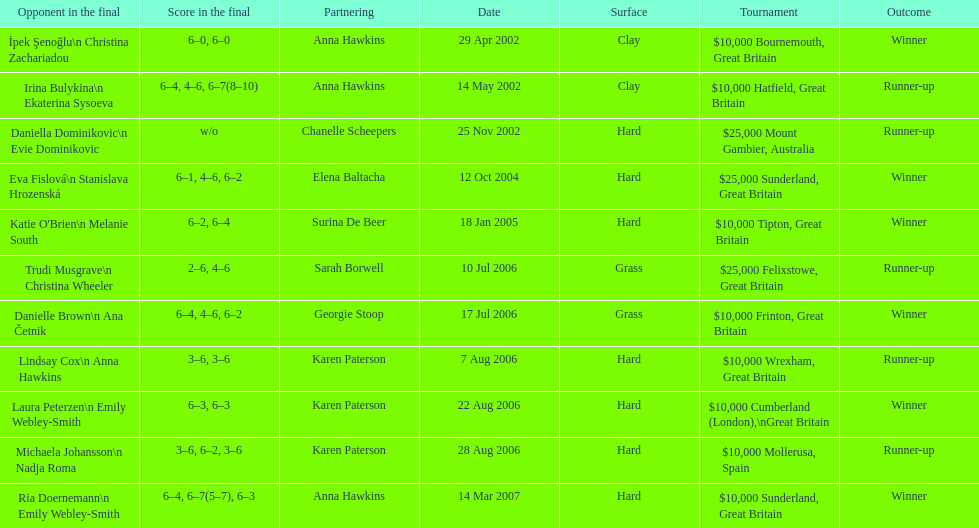How many surfaces are grass? 2. 